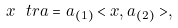Convert formula to latex. <formula><loc_0><loc_0><loc_500><loc_500>x \ t r a = a _ { ( 1 ) } < x , a _ { ( 2 ) } > ,</formula> 